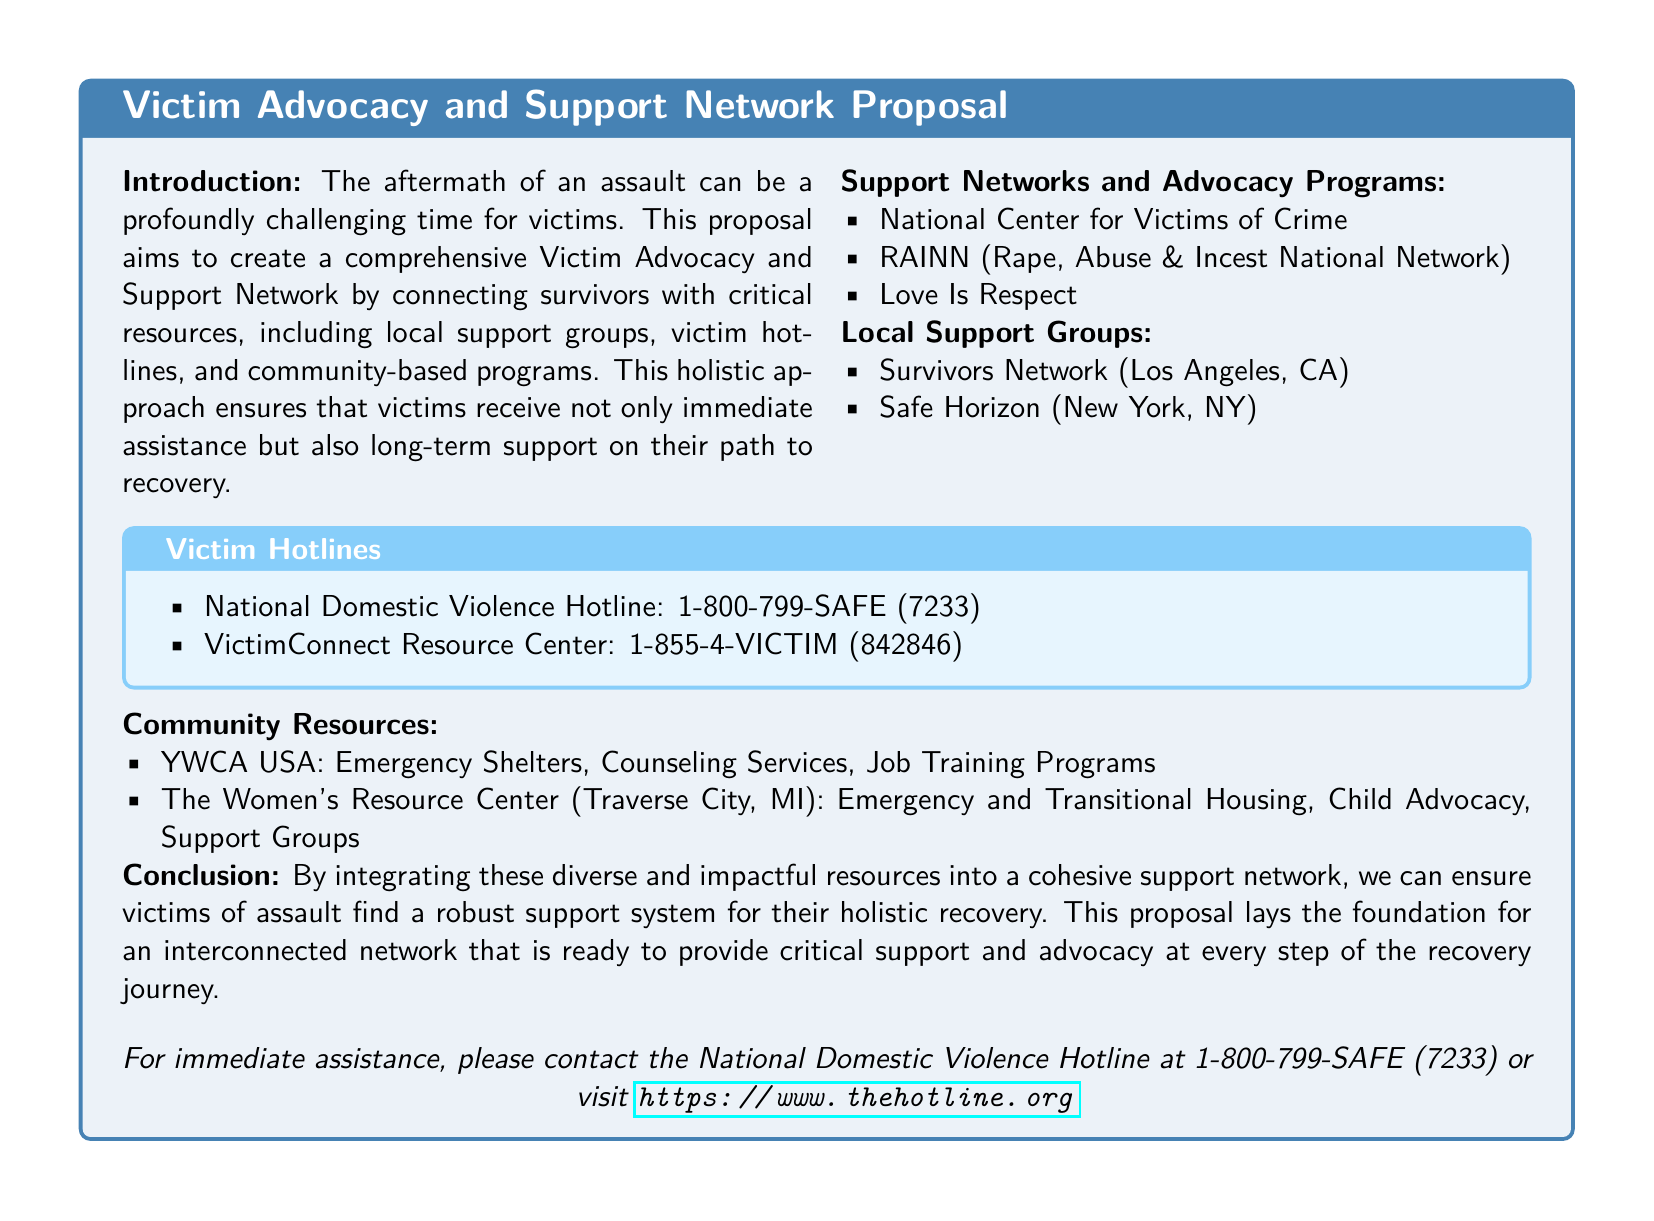What is the purpose of the proposal? The proposal aims to create a comprehensive Victim Advocacy and Support Network connecting survivors with critical resources.
Answer: Comprehensive Victim Advocacy and Support Network What hotline can I call for immediate assistance? The document specifies the National Domestic Violence Hotline for immediate assistance.
Answer: 1-800-799-SAFE (7233) Which network provides resources for crime victims? The National Center for Victims of Crime is mentioned as a support network.
Answer: National Center for Victims of Crime What type of services does YWCA USA offer? The document outlines specific services provided by YWCA USA, such as emergency shelters and counseling services.
Answer: Emergency Shelters, Counseling Services, Job Training Programs What is the focus of Love Is Respect? This organization is included as part of the support networks, implying its focus on respect and relationships.
Answer: Respect List a local support group in New York. The document lists Safe Horizon as a local support group in New York.
Answer: Safe Horizon What is the main goal of the proposed support network? The main goal of the network is to ensure victims receive both immediate assistance and long-term support.
Answer: Holistic recovery How many victim hotlines are listed in the document? There are two victim hotlines mentioned in the document for support.
Answer: 2 What type of housing does The Women's Resource Center provide? The Women's Resource Center provides emergency and transitional housing as part of its services.
Answer: Emergency and Transitional Housing 